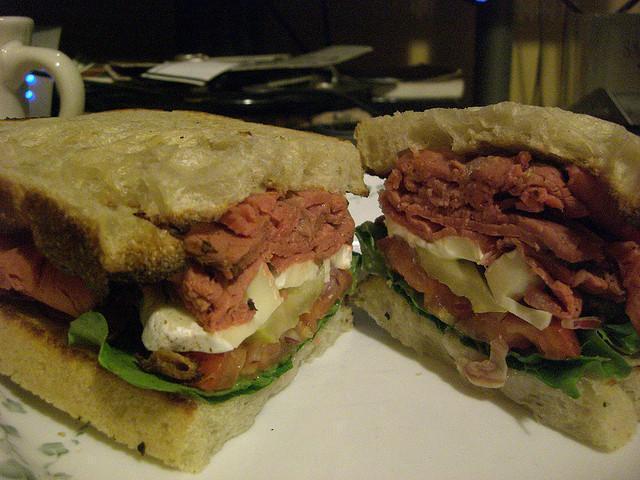How many sandwiches are there?
Give a very brief answer. 2. How many people are holding up their camera phones?
Give a very brief answer. 0. 